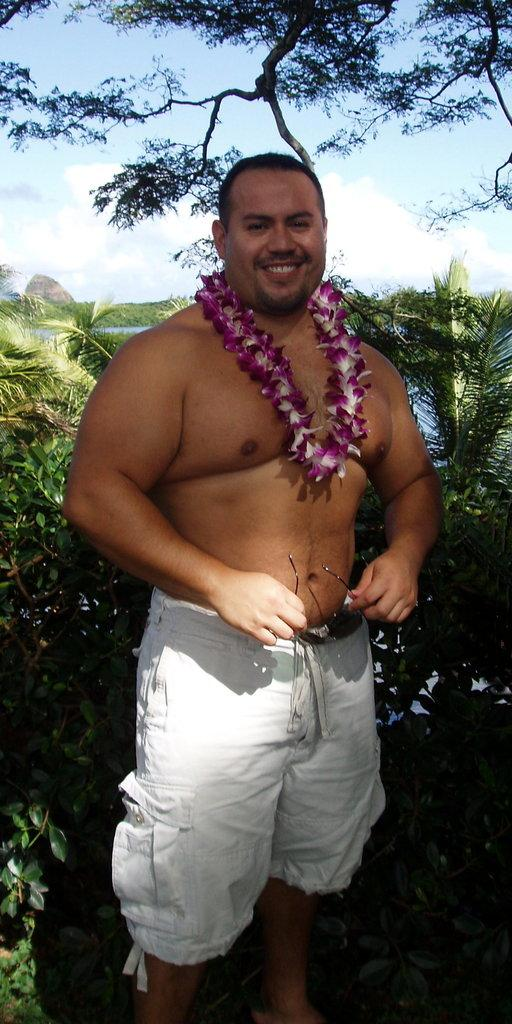What is the man in the image doing? The man is standing in the image. What is the man wearing around his neck? The man is wearing a garland. What type of clothing is the man wearing on his lower body? The man is wearing white shorts. What object is the man holding in his hands? The man is holding goggles in his hands. What type of natural environment can be seen in the image? There are trees and water visible in the image. What is visible at the top of the image? The sky is visible at the top of the image. Where is the brake located in the image? There is no brake present in the image. What page is the man reading in the image? There is no book or page visible in the image. 